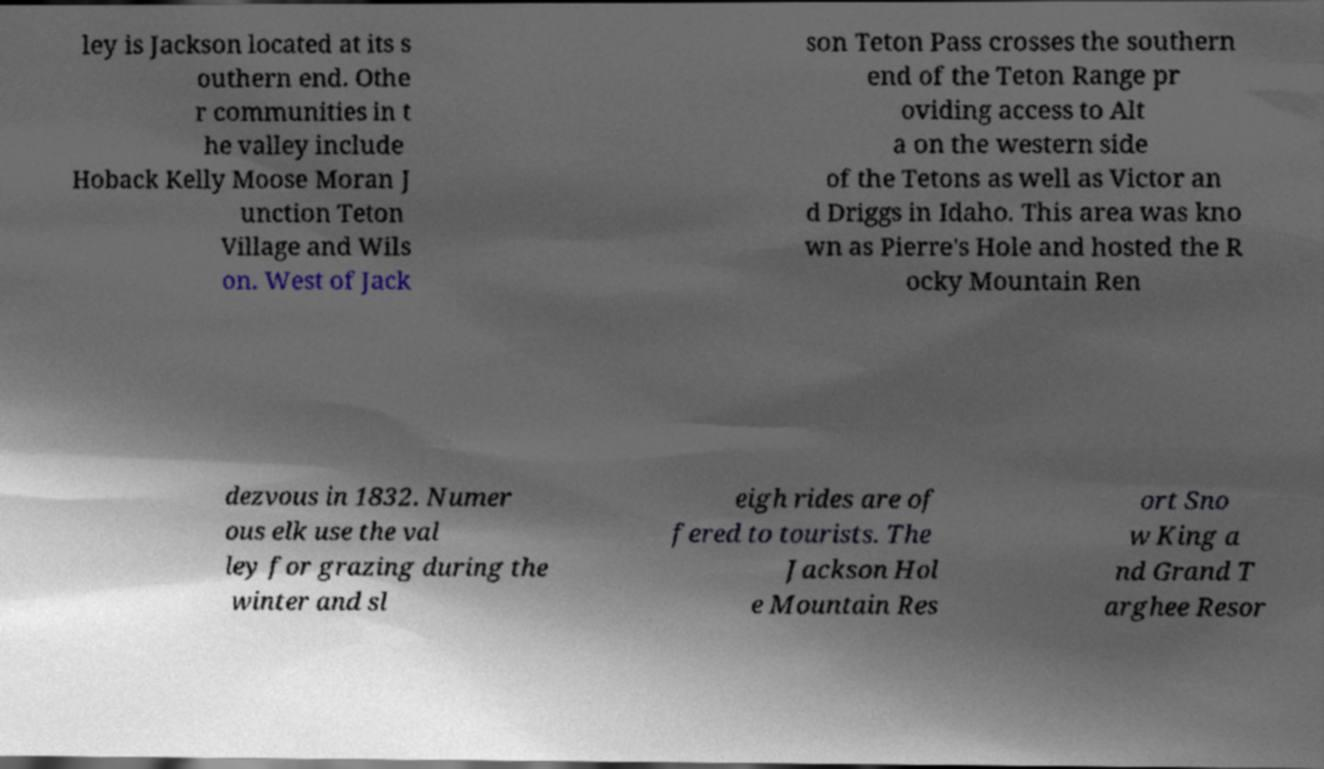Please read and relay the text visible in this image. What does it say? ley is Jackson located at its s outhern end. Othe r communities in t he valley include Hoback Kelly Moose Moran J unction Teton Village and Wils on. West of Jack son Teton Pass crosses the southern end of the Teton Range pr oviding access to Alt a on the western side of the Tetons as well as Victor an d Driggs in Idaho. This area was kno wn as Pierre's Hole and hosted the R ocky Mountain Ren dezvous in 1832. Numer ous elk use the val ley for grazing during the winter and sl eigh rides are of fered to tourists. The Jackson Hol e Mountain Res ort Sno w King a nd Grand T arghee Resor 